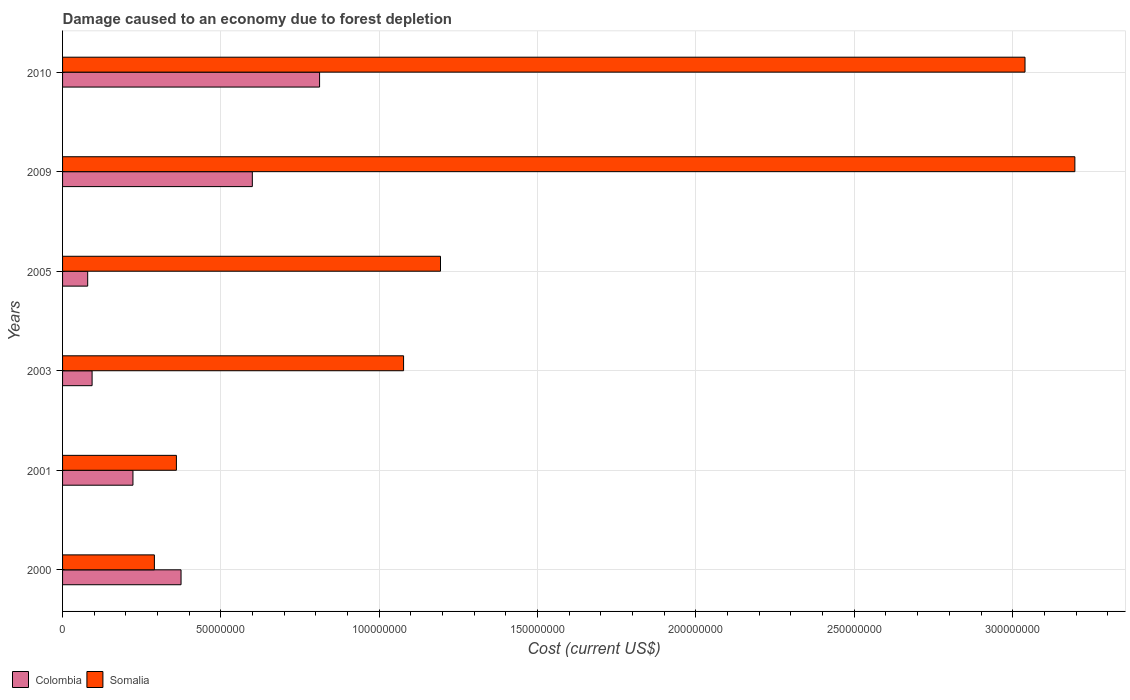How many groups of bars are there?
Provide a succinct answer. 6. Are the number of bars on each tick of the Y-axis equal?
Ensure brevity in your answer.  Yes. How many bars are there on the 6th tick from the top?
Ensure brevity in your answer.  2. What is the label of the 3rd group of bars from the top?
Your response must be concise. 2005. In how many cases, is the number of bars for a given year not equal to the number of legend labels?
Ensure brevity in your answer.  0. What is the cost of damage caused due to forest depletion in Colombia in 2000?
Your answer should be compact. 3.74e+07. Across all years, what is the maximum cost of damage caused due to forest depletion in Colombia?
Provide a succinct answer. 8.12e+07. Across all years, what is the minimum cost of damage caused due to forest depletion in Somalia?
Your response must be concise. 2.90e+07. In which year was the cost of damage caused due to forest depletion in Colombia maximum?
Your response must be concise. 2010. What is the total cost of damage caused due to forest depletion in Somalia in the graph?
Keep it short and to the point. 9.15e+08. What is the difference between the cost of damage caused due to forest depletion in Colombia in 2005 and that in 2010?
Make the answer very short. -7.32e+07. What is the difference between the cost of damage caused due to forest depletion in Somalia in 2009 and the cost of damage caused due to forest depletion in Colombia in 2003?
Your answer should be compact. 3.10e+08. What is the average cost of damage caused due to forest depletion in Somalia per year?
Your answer should be very brief. 1.53e+08. In the year 2001, what is the difference between the cost of damage caused due to forest depletion in Somalia and cost of damage caused due to forest depletion in Colombia?
Make the answer very short. 1.37e+07. What is the ratio of the cost of damage caused due to forest depletion in Somalia in 2001 to that in 2010?
Keep it short and to the point. 0.12. Is the cost of damage caused due to forest depletion in Somalia in 2001 less than that in 2009?
Make the answer very short. Yes. Is the difference between the cost of damage caused due to forest depletion in Somalia in 2001 and 2009 greater than the difference between the cost of damage caused due to forest depletion in Colombia in 2001 and 2009?
Make the answer very short. No. What is the difference between the highest and the second highest cost of damage caused due to forest depletion in Somalia?
Ensure brevity in your answer.  1.57e+07. What is the difference between the highest and the lowest cost of damage caused due to forest depletion in Colombia?
Your response must be concise. 7.32e+07. What does the 2nd bar from the bottom in 2000 represents?
Your response must be concise. Somalia. How many bars are there?
Offer a terse response. 12. Are all the bars in the graph horizontal?
Make the answer very short. Yes. What is the difference between two consecutive major ticks on the X-axis?
Your answer should be compact. 5.00e+07. Where does the legend appear in the graph?
Provide a succinct answer. Bottom left. How are the legend labels stacked?
Your answer should be very brief. Horizontal. What is the title of the graph?
Your answer should be very brief. Damage caused to an economy due to forest depletion. Does "Germany" appear as one of the legend labels in the graph?
Provide a succinct answer. No. What is the label or title of the X-axis?
Provide a short and direct response. Cost (current US$). What is the Cost (current US$) of Colombia in 2000?
Provide a succinct answer. 3.74e+07. What is the Cost (current US$) of Somalia in 2000?
Offer a very short reply. 2.90e+07. What is the Cost (current US$) in Colombia in 2001?
Offer a very short reply. 2.22e+07. What is the Cost (current US$) of Somalia in 2001?
Your answer should be very brief. 3.59e+07. What is the Cost (current US$) in Colombia in 2003?
Your answer should be very brief. 9.33e+06. What is the Cost (current US$) of Somalia in 2003?
Make the answer very short. 1.08e+08. What is the Cost (current US$) of Colombia in 2005?
Provide a short and direct response. 7.93e+06. What is the Cost (current US$) in Somalia in 2005?
Offer a terse response. 1.19e+08. What is the Cost (current US$) in Colombia in 2009?
Your answer should be compact. 5.99e+07. What is the Cost (current US$) in Somalia in 2009?
Offer a terse response. 3.20e+08. What is the Cost (current US$) of Colombia in 2010?
Ensure brevity in your answer.  8.12e+07. What is the Cost (current US$) in Somalia in 2010?
Give a very brief answer. 3.04e+08. Across all years, what is the maximum Cost (current US$) of Colombia?
Your response must be concise. 8.12e+07. Across all years, what is the maximum Cost (current US$) in Somalia?
Make the answer very short. 3.20e+08. Across all years, what is the minimum Cost (current US$) of Colombia?
Ensure brevity in your answer.  7.93e+06. Across all years, what is the minimum Cost (current US$) of Somalia?
Provide a short and direct response. 2.90e+07. What is the total Cost (current US$) of Colombia in the graph?
Keep it short and to the point. 2.18e+08. What is the total Cost (current US$) of Somalia in the graph?
Ensure brevity in your answer.  9.15e+08. What is the difference between the Cost (current US$) of Colombia in 2000 and that in 2001?
Your answer should be very brief. 1.52e+07. What is the difference between the Cost (current US$) of Somalia in 2000 and that in 2001?
Make the answer very short. -6.95e+06. What is the difference between the Cost (current US$) in Colombia in 2000 and that in 2003?
Ensure brevity in your answer.  2.81e+07. What is the difference between the Cost (current US$) of Somalia in 2000 and that in 2003?
Make the answer very short. -7.87e+07. What is the difference between the Cost (current US$) of Colombia in 2000 and that in 2005?
Your answer should be very brief. 2.95e+07. What is the difference between the Cost (current US$) in Somalia in 2000 and that in 2005?
Provide a short and direct response. -9.03e+07. What is the difference between the Cost (current US$) in Colombia in 2000 and that in 2009?
Offer a terse response. -2.25e+07. What is the difference between the Cost (current US$) in Somalia in 2000 and that in 2009?
Give a very brief answer. -2.91e+08. What is the difference between the Cost (current US$) of Colombia in 2000 and that in 2010?
Provide a short and direct response. -4.37e+07. What is the difference between the Cost (current US$) of Somalia in 2000 and that in 2010?
Your answer should be very brief. -2.75e+08. What is the difference between the Cost (current US$) in Colombia in 2001 and that in 2003?
Offer a terse response. 1.29e+07. What is the difference between the Cost (current US$) of Somalia in 2001 and that in 2003?
Keep it short and to the point. -7.17e+07. What is the difference between the Cost (current US$) of Colombia in 2001 and that in 2005?
Your answer should be compact. 1.43e+07. What is the difference between the Cost (current US$) of Somalia in 2001 and that in 2005?
Make the answer very short. -8.34e+07. What is the difference between the Cost (current US$) of Colombia in 2001 and that in 2009?
Offer a very short reply. -3.77e+07. What is the difference between the Cost (current US$) in Somalia in 2001 and that in 2009?
Keep it short and to the point. -2.84e+08. What is the difference between the Cost (current US$) in Colombia in 2001 and that in 2010?
Your response must be concise. -5.89e+07. What is the difference between the Cost (current US$) in Somalia in 2001 and that in 2010?
Offer a terse response. -2.68e+08. What is the difference between the Cost (current US$) of Colombia in 2003 and that in 2005?
Give a very brief answer. 1.39e+06. What is the difference between the Cost (current US$) of Somalia in 2003 and that in 2005?
Provide a short and direct response. -1.17e+07. What is the difference between the Cost (current US$) in Colombia in 2003 and that in 2009?
Your response must be concise. -5.06e+07. What is the difference between the Cost (current US$) of Somalia in 2003 and that in 2009?
Offer a terse response. -2.12e+08. What is the difference between the Cost (current US$) in Colombia in 2003 and that in 2010?
Give a very brief answer. -7.18e+07. What is the difference between the Cost (current US$) of Somalia in 2003 and that in 2010?
Your answer should be compact. -1.96e+08. What is the difference between the Cost (current US$) in Colombia in 2005 and that in 2009?
Your response must be concise. -5.20e+07. What is the difference between the Cost (current US$) in Somalia in 2005 and that in 2009?
Offer a terse response. -2.00e+08. What is the difference between the Cost (current US$) in Colombia in 2005 and that in 2010?
Make the answer very short. -7.32e+07. What is the difference between the Cost (current US$) in Somalia in 2005 and that in 2010?
Ensure brevity in your answer.  -1.85e+08. What is the difference between the Cost (current US$) in Colombia in 2009 and that in 2010?
Offer a terse response. -2.12e+07. What is the difference between the Cost (current US$) of Somalia in 2009 and that in 2010?
Provide a succinct answer. 1.57e+07. What is the difference between the Cost (current US$) in Colombia in 2000 and the Cost (current US$) in Somalia in 2001?
Give a very brief answer. 1.47e+06. What is the difference between the Cost (current US$) of Colombia in 2000 and the Cost (current US$) of Somalia in 2003?
Offer a terse response. -7.03e+07. What is the difference between the Cost (current US$) in Colombia in 2000 and the Cost (current US$) in Somalia in 2005?
Make the answer very short. -8.19e+07. What is the difference between the Cost (current US$) of Colombia in 2000 and the Cost (current US$) of Somalia in 2009?
Offer a terse response. -2.82e+08. What is the difference between the Cost (current US$) of Colombia in 2000 and the Cost (current US$) of Somalia in 2010?
Provide a short and direct response. -2.66e+08. What is the difference between the Cost (current US$) in Colombia in 2001 and the Cost (current US$) in Somalia in 2003?
Offer a very short reply. -8.55e+07. What is the difference between the Cost (current US$) in Colombia in 2001 and the Cost (current US$) in Somalia in 2005?
Ensure brevity in your answer.  -9.71e+07. What is the difference between the Cost (current US$) of Colombia in 2001 and the Cost (current US$) of Somalia in 2009?
Offer a very short reply. -2.97e+08. What is the difference between the Cost (current US$) in Colombia in 2001 and the Cost (current US$) in Somalia in 2010?
Provide a short and direct response. -2.82e+08. What is the difference between the Cost (current US$) of Colombia in 2003 and the Cost (current US$) of Somalia in 2005?
Provide a succinct answer. -1.10e+08. What is the difference between the Cost (current US$) in Colombia in 2003 and the Cost (current US$) in Somalia in 2009?
Offer a terse response. -3.10e+08. What is the difference between the Cost (current US$) of Colombia in 2003 and the Cost (current US$) of Somalia in 2010?
Keep it short and to the point. -2.95e+08. What is the difference between the Cost (current US$) of Colombia in 2005 and the Cost (current US$) of Somalia in 2009?
Keep it short and to the point. -3.12e+08. What is the difference between the Cost (current US$) of Colombia in 2005 and the Cost (current US$) of Somalia in 2010?
Ensure brevity in your answer.  -2.96e+08. What is the difference between the Cost (current US$) of Colombia in 2009 and the Cost (current US$) of Somalia in 2010?
Give a very brief answer. -2.44e+08. What is the average Cost (current US$) of Colombia per year?
Provide a short and direct response. 3.63e+07. What is the average Cost (current US$) in Somalia per year?
Your response must be concise. 1.53e+08. In the year 2000, what is the difference between the Cost (current US$) of Colombia and Cost (current US$) of Somalia?
Your response must be concise. 8.41e+06. In the year 2001, what is the difference between the Cost (current US$) in Colombia and Cost (current US$) in Somalia?
Offer a very short reply. -1.37e+07. In the year 2003, what is the difference between the Cost (current US$) of Colombia and Cost (current US$) of Somalia?
Your response must be concise. -9.83e+07. In the year 2005, what is the difference between the Cost (current US$) in Colombia and Cost (current US$) in Somalia?
Your answer should be compact. -1.11e+08. In the year 2009, what is the difference between the Cost (current US$) of Colombia and Cost (current US$) of Somalia?
Give a very brief answer. -2.60e+08. In the year 2010, what is the difference between the Cost (current US$) of Colombia and Cost (current US$) of Somalia?
Give a very brief answer. -2.23e+08. What is the ratio of the Cost (current US$) of Colombia in 2000 to that in 2001?
Provide a succinct answer. 1.68. What is the ratio of the Cost (current US$) of Somalia in 2000 to that in 2001?
Ensure brevity in your answer.  0.81. What is the ratio of the Cost (current US$) in Colombia in 2000 to that in 2003?
Your answer should be very brief. 4.01. What is the ratio of the Cost (current US$) of Somalia in 2000 to that in 2003?
Give a very brief answer. 0.27. What is the ratio of the Cost (current US$) of Colombia in 2000 to that in 2005?
Your answer should be very brief. 4.71. What is the ratio of the Cost (current US$) of Somalia in 2000 to that in 2005?
Provide a succinct answer. 0.24. What is the ratio of the Cost (current US$) in Colombia in 2000 to that in 2009?
Provide a succinct answer. 0.62. What is the ratio of the Cost (current US$) in Somalia in 2000 to that in 2009?
Offer a very short reply. 0.09. What is the ratio of the Cost (current US$) in Colombia in 2000 to that in 2010?
Provide a succinct answer. 0.46. What is the ratio of the Cost (current US$) of Somalia in 2000 to that in 2010?
Give a very brief answer. 0.1. What is the ratio of the Cost (current US$) in Colombia in 2001 to that in 2003?
Give a very brief answer. 2.38. What is the ratio of the Cost (current US$) in Somalia in 2001 to that in 2003?
Keep it short and to the point. 0.33. What is the ratio of the Cost (current US$) of Colombia in 2001 to that in 2005?
Your answer should be compact. 2.8. What is the ratio of the Cost (current US$) in Somalia in 2001 to that in 2005?
Make the answer very short. 0.3. What is the ratio of the Cost (current US$) in Colombia in 2001 to that in 2009?
Provide a short and direct response. 0.37. What is the ratio of the Cost (current US$) in Somalia in 2001 to that in 2009?
Provide a short and direct response. 0.11. What is the ratio of the Cost (current US$) in Colombia in 2001 to that in 2010?
Provide a succinct answer. 0.27. What is the ratio of the Cost (current US$) in Somalia in 2001 to that in 2010?
Offer a very short reply. 0.12. What is the ratio of the Cost (current US$) in Colombia in 2003 to that in 2005?
Your response must be concise. 1.18. What is the ratio of the Cost (current US$) of Somalia in 2003 to that in 2005?
Give a very brief answer. 0.9. What is the ratio of the Cost (current US$) of Colombia in 2003 to that in 2009?
Make the answer very short. 0.16. What is the ratio of the Cost (current US$) in Somalia in 2003 to that in 2009?
Ensure brevity in your answer.  0.34. What is the ratio of the Cost (current US$) of Colombia in 2003 to that in 2010?
Keep it short and to the point. 0.11. What is the ratio of the Cost (current US$) of Somalia in 2003 to that in 2010?
Make the answer very short. 0.35. What is the ratio of the Cost (current US$) in Colombia in 2005 to that in 2009?
Make the answer very short. 0.13. What is the ratio of the Cost (current US$) in Somalia in 2005 to that in 2009?
Provide a succinct answer. 0.37. What is the ratio of the Cost (current US$) in Colombia in 2005 to that in 2010?
Make the answer very short. 0.1. What is the ratio of the Cost (current US$) in Somalia in 2005 to that in 2010?
Keep it short and to the point. 0.39. What is the ratio of the Cost (current US$) of Colombia in 2009 to that in 2010?
Your answer should be very brief. 0.74. What is the ratio of the Cost (current US$) in Somalia in 2009 to that in 2010?
Make the answer very short. 1.05. What is the difference between the highest and the second highest Cost (current US$) in Colombia?
Keep it short and to the point. 2.12e+07. What is the difference between the highest and the second highest Cost (current US$) in Somalia?
Ensure brevity in your answer.  1.57e+07. What is the difference between the highest and the lowest Cost (current US$) in Colombia?
Your answer should be very brief. 7.32e+07. What is the difference between the highest and the lowest Cost (current US$) of Somalia?
Provide a succinct answer. 2.91e+08. 